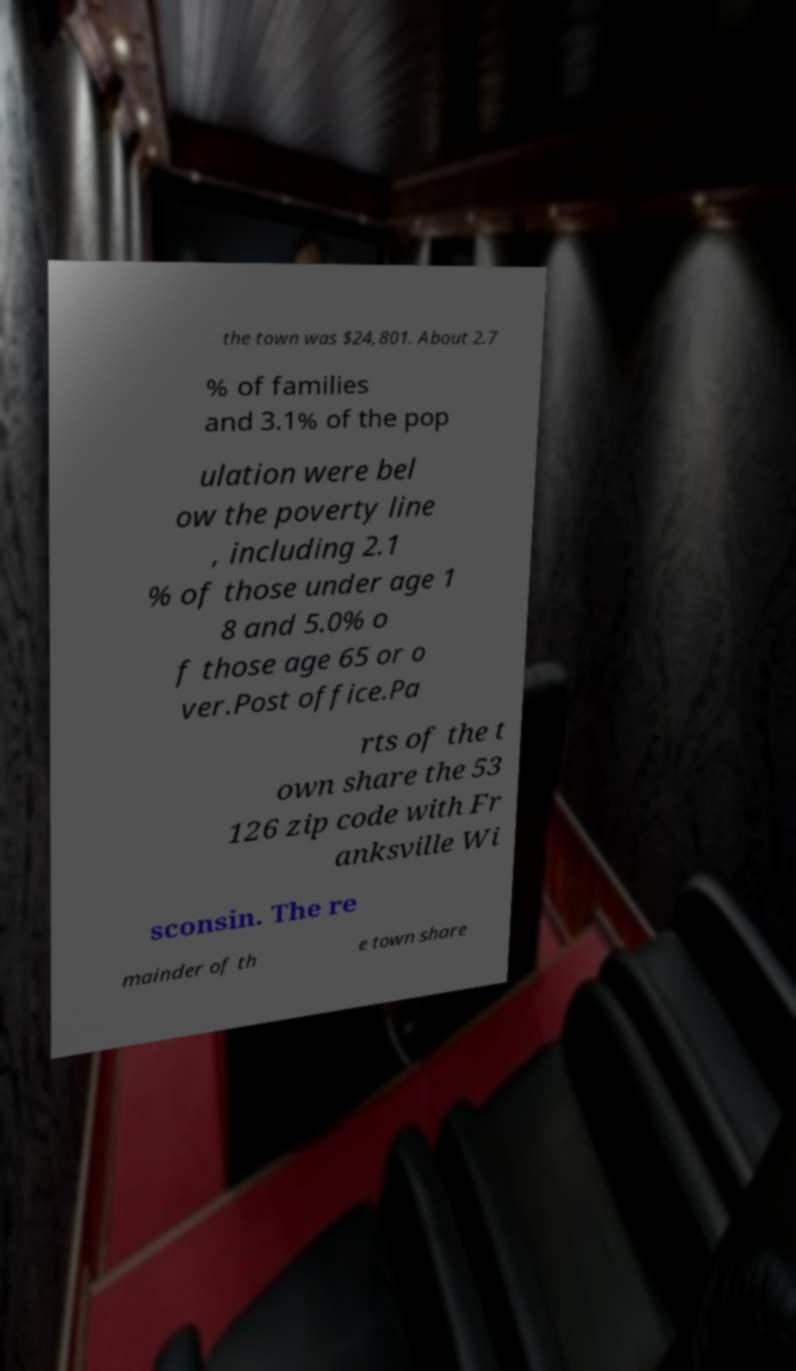Please identify and transcribe the text found in this image. the town was $24,801. About 2.7 % of families and 3.1% of the pop ulation were bel ow the poverty line , including 2.1 % of those under age 1 8 and 5.0% o f those age 65 or o ver.Post office.Pa rts of the t own share the 53 126 zip code with Fr anksville Wi sconsin. The re mainder of th e town share 